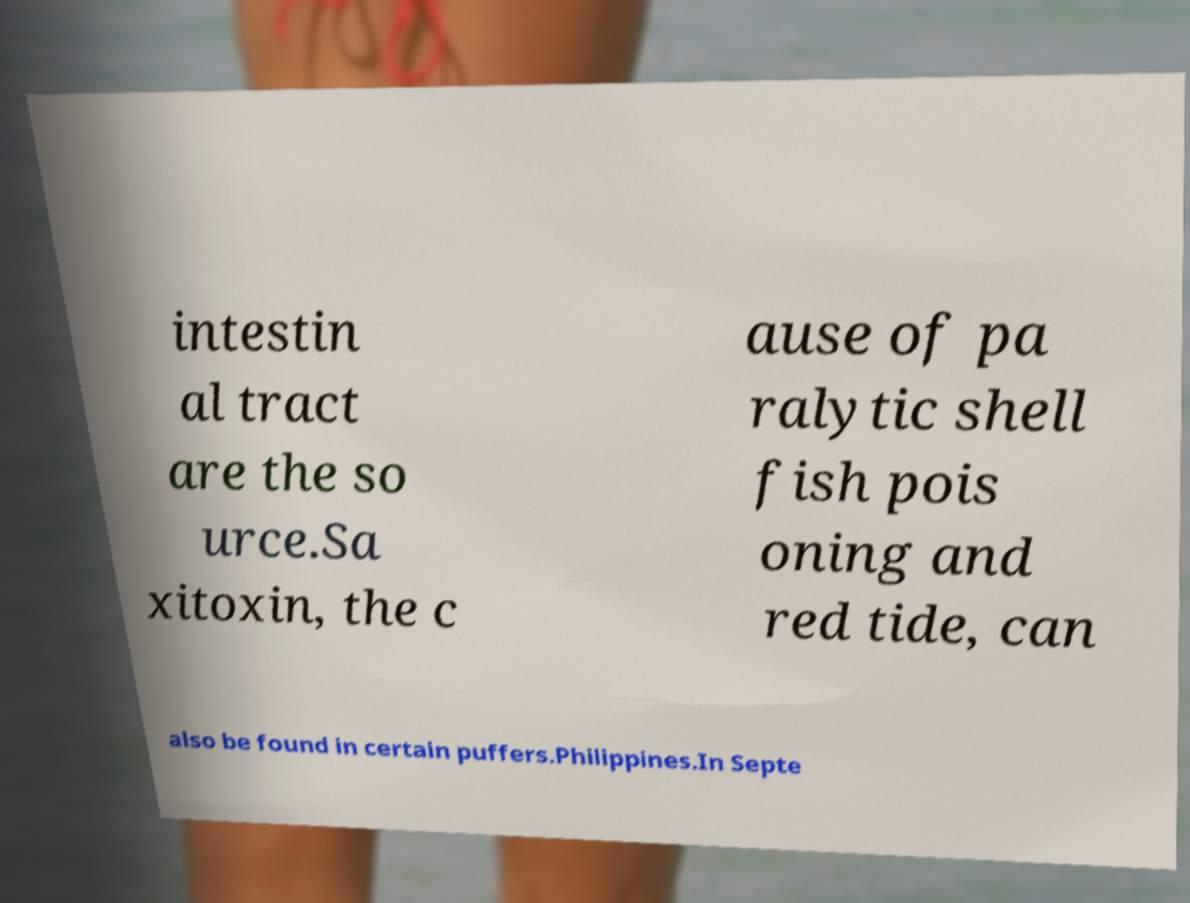There's text embedded in this image that I need extracted. Can you transcribe it verbatim? intestin al tract are the so urce.Sa xitoxin, the c ause of pa ralytic shell fish pois oning and red tide, can also be found in certain puffers.Philippines.In Septe 